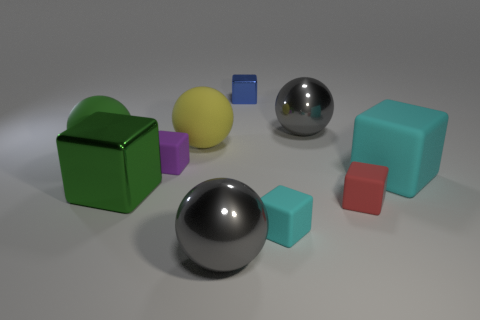Subtract all big green spheres. How many spheres are left? 3 Subtract all green balls. How many balls are left? 3 Subtract all spheres. How many objects are left? 6 Subtract all red cubes. How many brown balls are left? 0 Subtract all tiny red matte blocks. Subtract all big cyan rubber objects. How many objects are left? 8 Add 1 large green matte spheres. How many large green matte spheres are left? 2 Add 6 green metallic blocks. How many green metallic blocks exist? 7 Subtract 1 red cubes. How many objects are left? 9 Subtract 1 blocks. How many blocks are left? 5 Subtract all blue balls. Subtract all purple cylinders. How many balls are left? 4 